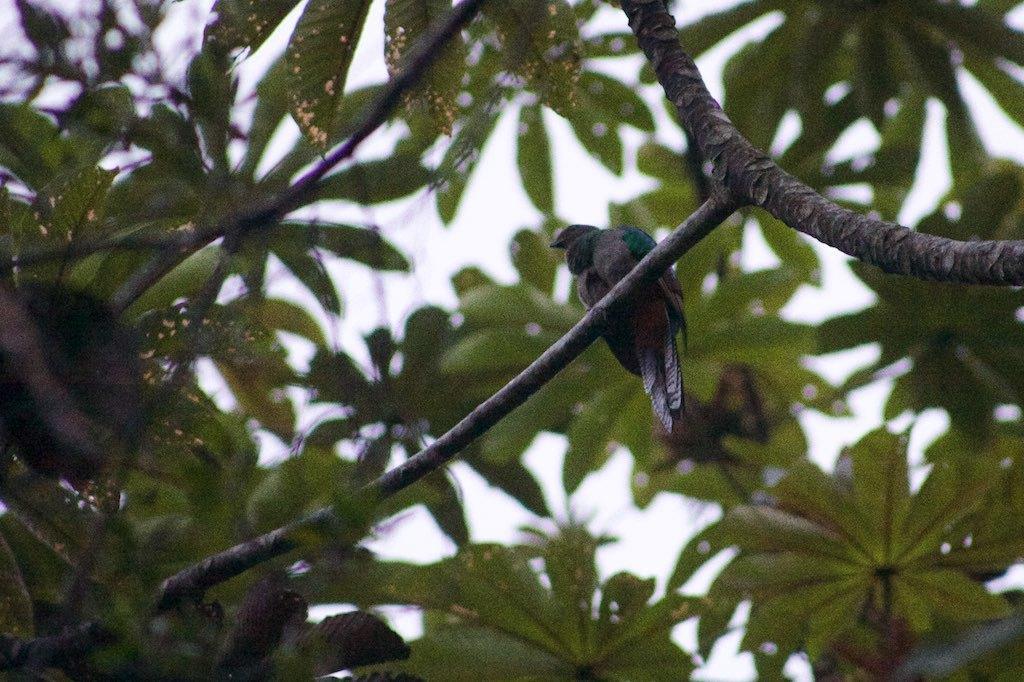Describe this image in one or two sentences. In this image there is a bird sitting on the branch of a tree. 